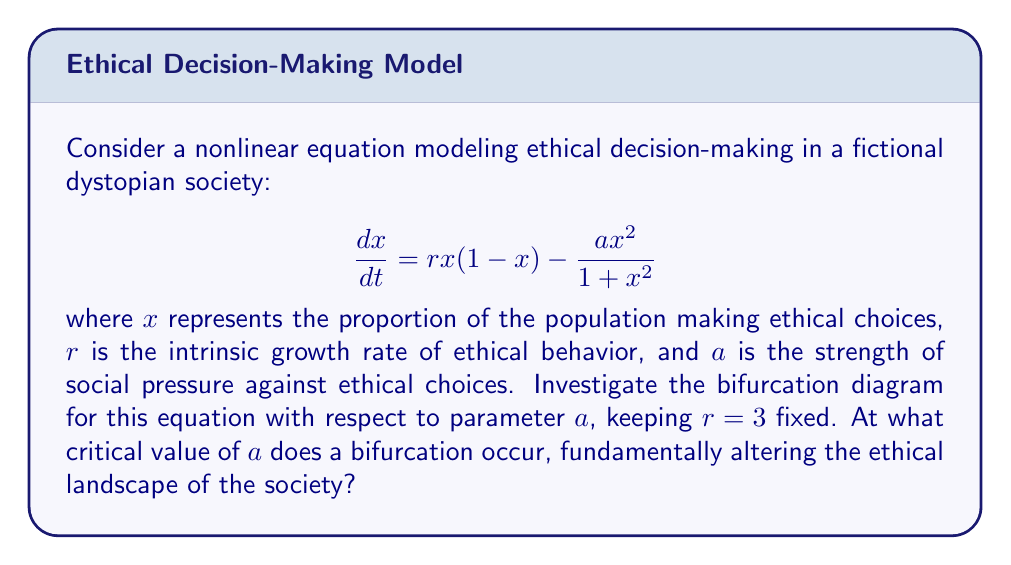Teach me how to tackle this problem. To investigate the bifurcation diagram, we need to follow these steps:

1) Find the equilibrium points by setting $\frac{dx}{dt} = 0$:

   $$rx(1-x) - \frac{ax^2}{1+x^2} = 0$$

2) Simplify the equation:

   $$3x(1-x)(1+x^2) = ax^2$$
   $$3x + 3x^3 - 3x^2 - 3x^4 = ax^2$$
   $$3x^3 - 3x^4 + 3x - (a+3)x^2 = 0$$
   $$x(3x^2 - 3x^3 + 3 - (a+3)x) = 0$$

3) One equilibrium point is always $x=0$. For the others, solve:

   $$3x^2 - 3x^3 + 3 - (a+3)x = 0$$

4) This is a cubic equation. The number of real roots (excluding $x=0$) will change as $a$ varies, indicating a bifurcation.

5) A bifurcation occurs when this cubic has a double root, which happens when its discriminant is zero. The discriminant of a cubic $ax^3 + bx^2 + cx + d = 0$ is:

   $$\Delta = 18abcd - 4b^3d + b^2c^2 - 4ac^3 - 27a^2d^2$$

6) In our case, $a=-3$, $b=3$, $c=-(a+3)$, and $d=3$. Substituting these into the discriminant formula:

   $$\Delta = -27(a+3)^2 + 243(a+3) - 729 = 0$$

7) Solve this quadratic equation in $a$:

   $$27(a+3)^2 - 243(a+3) + 729 = 0$$
   $$(a+3)^2 - 9(a+3) + 27 = 0$$
   Let $y = a+3$, then:
   $$y^2 - 9y + 27 = 0$$
   $$(y-3)(y-6) = 0$$
   So $y = 3$ or $y = 6$

8) Therefore, $a = 0$ or $a = 3$. The smaller value corresponds to the bifurcation point.

Thus, the critical value of $a$ at which the bifurcation occurs is 0.
Answer: $a = 0$ 